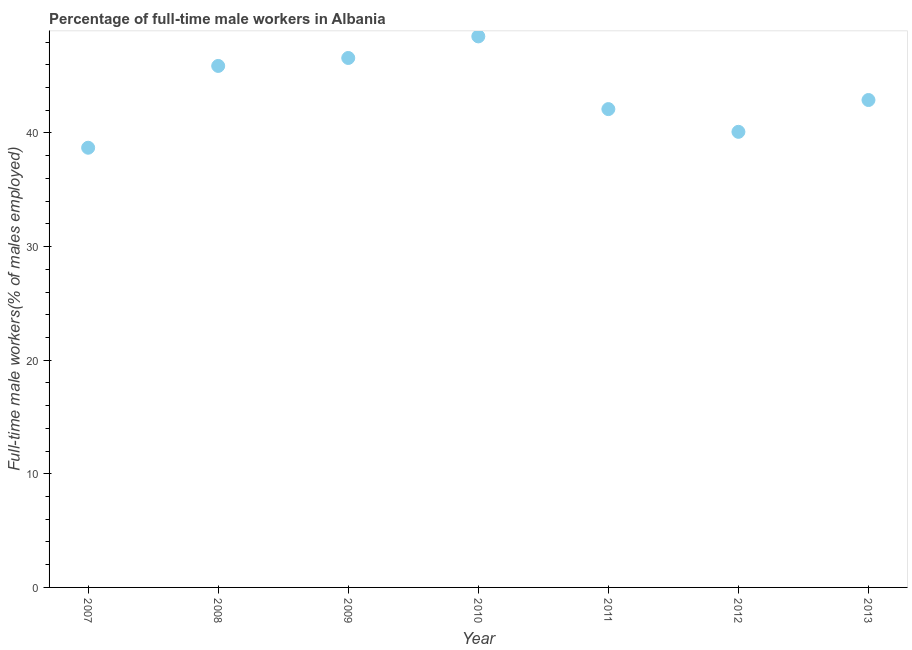What is the percentage of full-time male workers in 2012?
Offer a very short reply. 40.1. Across all years, what is the maximum percentage of full-time male workers?
Provide a short and direct response. 48.5. Across all years, what is the minimum percentage of full-time male workers?
Provide a succinct answer. 38.7. What is the sum of the percentage of full-time male workers?
Offer a very short reply. 304.8. What is the difference between the percentage of full-time male workers in 2010 and 2012?
Your answer should be compact. 8.4. What is the average percentage of full-time male workers per year?
Offer a terse response. 43.54. What is the median percentage of full-time male workers?
Offer a terse response. 42.9. In how many years, is the percentage of full-time male workers greater than 46 %?
Make the answer very short. 2. Do a majority of the years between 2009 and 2011 (inclusive) have percentage of full-time male workers greater than 4 %?
Offer a very short reply. Yes. What is the ratio of the percentage of full-time male workers in 2008 to that in 2013?
Offer a terse response. 1.07. What is the difference between the highest and the second highest percentage of full-time male workers?
Keep it short and to the point. 1.9. Is the sum of the percentage of full-time male workers in 2008 and 2009 greater than the maximum percentage of full-time male workers across all years?
Provide a succinct answer. Yes. What is the difference between the highest and the lowest percentage of full-time male workers?
Provide a succinct answer. 9.8. In how many years, is the percentage of full-time male workers greater than the average percentage of full-time male workers taken over all years?
Your answer should be compact. 3. Does the percentage of full-time male workers monotonically increase over the years?
Ensure brevity in your answer.  No. How many dotlines are there?
Provide a short and direct response. 1. How many years are there in the graph?
Your answer should be compact. 7. What is the difference between two consecutive major ticks on the Y-axis?
Offer a very short reply. 10. Are the values on the major ticks of Y-axis written in scientific E-notation?
Your response must be concise. No. What is the title of the graph?
Provide a succinct answer. Percentage of full-time male workers in Albania. What is the label or title of the X-axis?
Offer a terse response. Year. What is the label or title of the Y-axis?
Offer a terse response. Full-time male workers(% of males employed). What is the Full-time male workers(% of males employed) in 2007?
Give a very brief answer. 38.7. What is the Full-time male workers(% of males employed) in 2008?
Make the answer very short. 45.9. What is the Full-time male workers(% of males employed) in 2009?
Give a very brief answer. 46.6. What is the Full-time male workers(% of males employed) in 2010?
Provide a short and direct response. 48.5. What is the Full-time male workers(% of males employed) in 2011?
Offer a very short reply. 42.1. What is the Full-time male workers(% of males employed) in 2012?
Offer a very short reply. 40.1. What is the Full-time male workers(% of males employed) in 2013?
Offer a terse response. 42.9. What is the difference between the Full-time male workers(% of males employed) in 2007 and 2008?
Keep it short and to the point. -7.2. What is the difference between the Full-time male workers(% of males employed) in 2007 and 2010?
Ensure brevity in your answer.  -9.8. What is the difference between the Full-time male workers(% of males employed) in 2007 and 2012?
Give a very brief answer. -1.4. What is the difference between the Full-time male workers(% of males employed) in 2007 and 2013?
Make the answer very short. -4.2. What is the difference between the Full-time male workers(% of males employed) in 2008 and 2009?
Give a very brief answer. -0.7. What is the difference between the Full-time male workers(% of males employed) in 2008 and 2012?
Give a very brief answer. 5.8. What is the difference between the Full-time male workers(% of males employed) in 2009 and 2010?
Make the answer very short. -1.9. What is the difference between the Full-time male workers(% of males employed) in 2009 and 2012?
Ensure brevity in your answer.  6.5. What is the difference between the Full-time male workers(% of males employed) in 2009 and 2013?
Your answer should be compact. 3.7. What is the difference between the Full-time male workers(% of males employed) in 2010 and 2013?
Your answer should be very brief. 5.6. What is the difference between the Full-time male workers(% of males employed) in 2011 and 2012?
Offer a terse response. 2. What is the ratio of the Full-time male workers(% of males employed) in 2007 to that in 2008?
Your answer should be very brief. 0.84. What is the ratio of the Full-time male workers(% of males employed) in 2007 to that in 2009?
Give a very brief answer. 0.83. What is the ratio of the Full-time male workers(% of males employed) in 2007 to that in 2010?
Your response must be concise. 0.8. What is the ratio of the Full-time male workers(% of males employed) in 2007 to that in 2011?
Offer a very short reply. 0.92. What is the ratio of the Full-time male workers(% of males employed) in 2007 to that in 2012?
Offer a terse response. 0.96. What is the ratio of the Full-time male workers(% of males employed) in 2007 to that in 2013?
Offer a terse response. 0.9. What is the ratio of the Full-time male workers(% of males employed) in 2008 to that in 2009?
Your answer should be very brief. 0.98. What is the ratio of the Full-time male workers(% of males employed) in 2008 to that in 2010?
Make the answer very short. 0.95. What is the ratio of the Full-time male workers(% of males employed) in 2008 to that in 2011?
Provide a short and direct response. 1.09. What is the ratio of the Full-time male workers(% of males employed) in 2008 to that in 2012?
Provide a short and direct response. 1.15. What is the ratio of the Full-time male workers(% of males employed) in 2008 to that in 2013?
Your answer should be compact. 1.07. What is the ratio of the Full-time male workers(% of males employed) in 2009 to that in 2011?
Your response must be concise. 1.11. What is the ratio of the Full-time male workers(% of males employed) in 2009 to that in 2012?
Your answer should be very brief. 1.16. What is the ratio of the Full-time male workers(% of males employed) in 2009 to that in 2013?
Your response must be concise. 1.09. What is the ratio of the Full-time male workers(% of males employed) in 2010 to that in 2011?
Your answer should be compact. 1.15. What is the ratio of the Full-time male workers(% of males employed) in 2010 to that in 2012?
Provide a succinct answer. 1.21. What is the ratio of the Full-time male workers(% of males employed) in 2010 to that in 2013?
Your answer should be very brief. 1.13. What is the ratio of the Full-time male workers(% of males employed) in 2012 to that in 2013?
Offer a terse response. 0.94. 